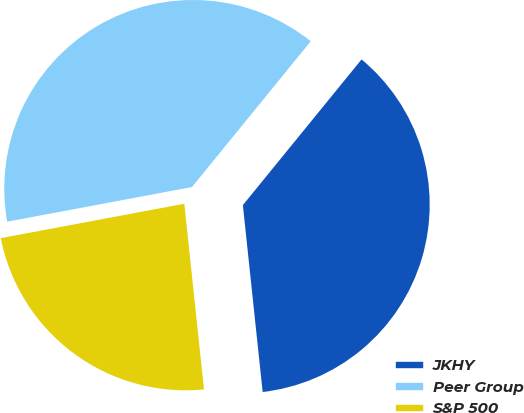<chart> <loc_0><loc_0><loc_500><loc_500><pie_chart><fcel>JKHY<fcel>Peer Group<fcel>S&P 500<nl><fcel>37.44%<fcel>38.83%<fcel>23.73%<nl></chart> 